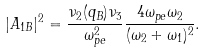<formula> <loc_0><loc_0><loc_500><loc_500>| A _ { 1 B } | ^ { 2 } = \frac { \nu _ { 2 } ( q _ { B } ) \nu _ { 3 } } { \omega _ { p e } ^ { 2 } } \frac { 4 \omega _ { p e } \omega _ { 2 } } { ( \omega _ { 2 } + \omega _ { 1 } ) ^ { 2 } } .</formula> 